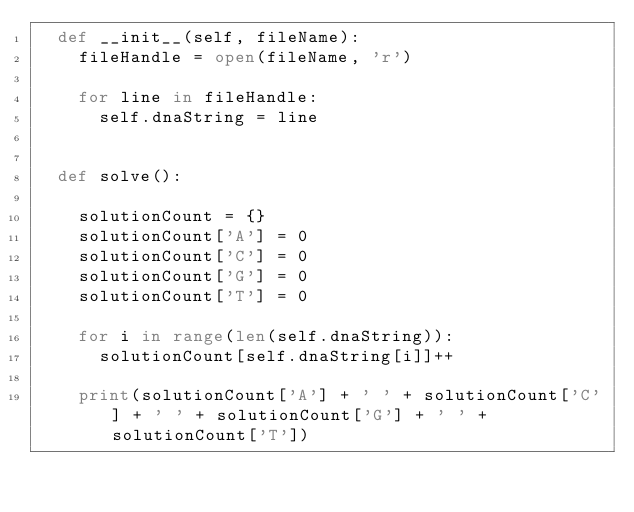<code> <loc_0><loc_0><loc_500><loc_500><_Python_>	def __init__(self, fileName):
		fileHandle = open(fileName, 'r')
	
		for line in fileHandle:
			self.dnaString = line		


	def solve():

		solutionCount = {}
		solutionCount['A'] = 0
		solutionCount['C'] = 0
		solutionCount['G'] = 0
		solutionCount['T'] = 0

		for i in range(len(self.dnaString)):
			solutionCount[self.dnaString[i]]++

		print(solutionCount['A'] + ' ' + solutionCount['C'] + ' ' + solutionCount['G'] + ' ' + solutionCount['T'])</code> 